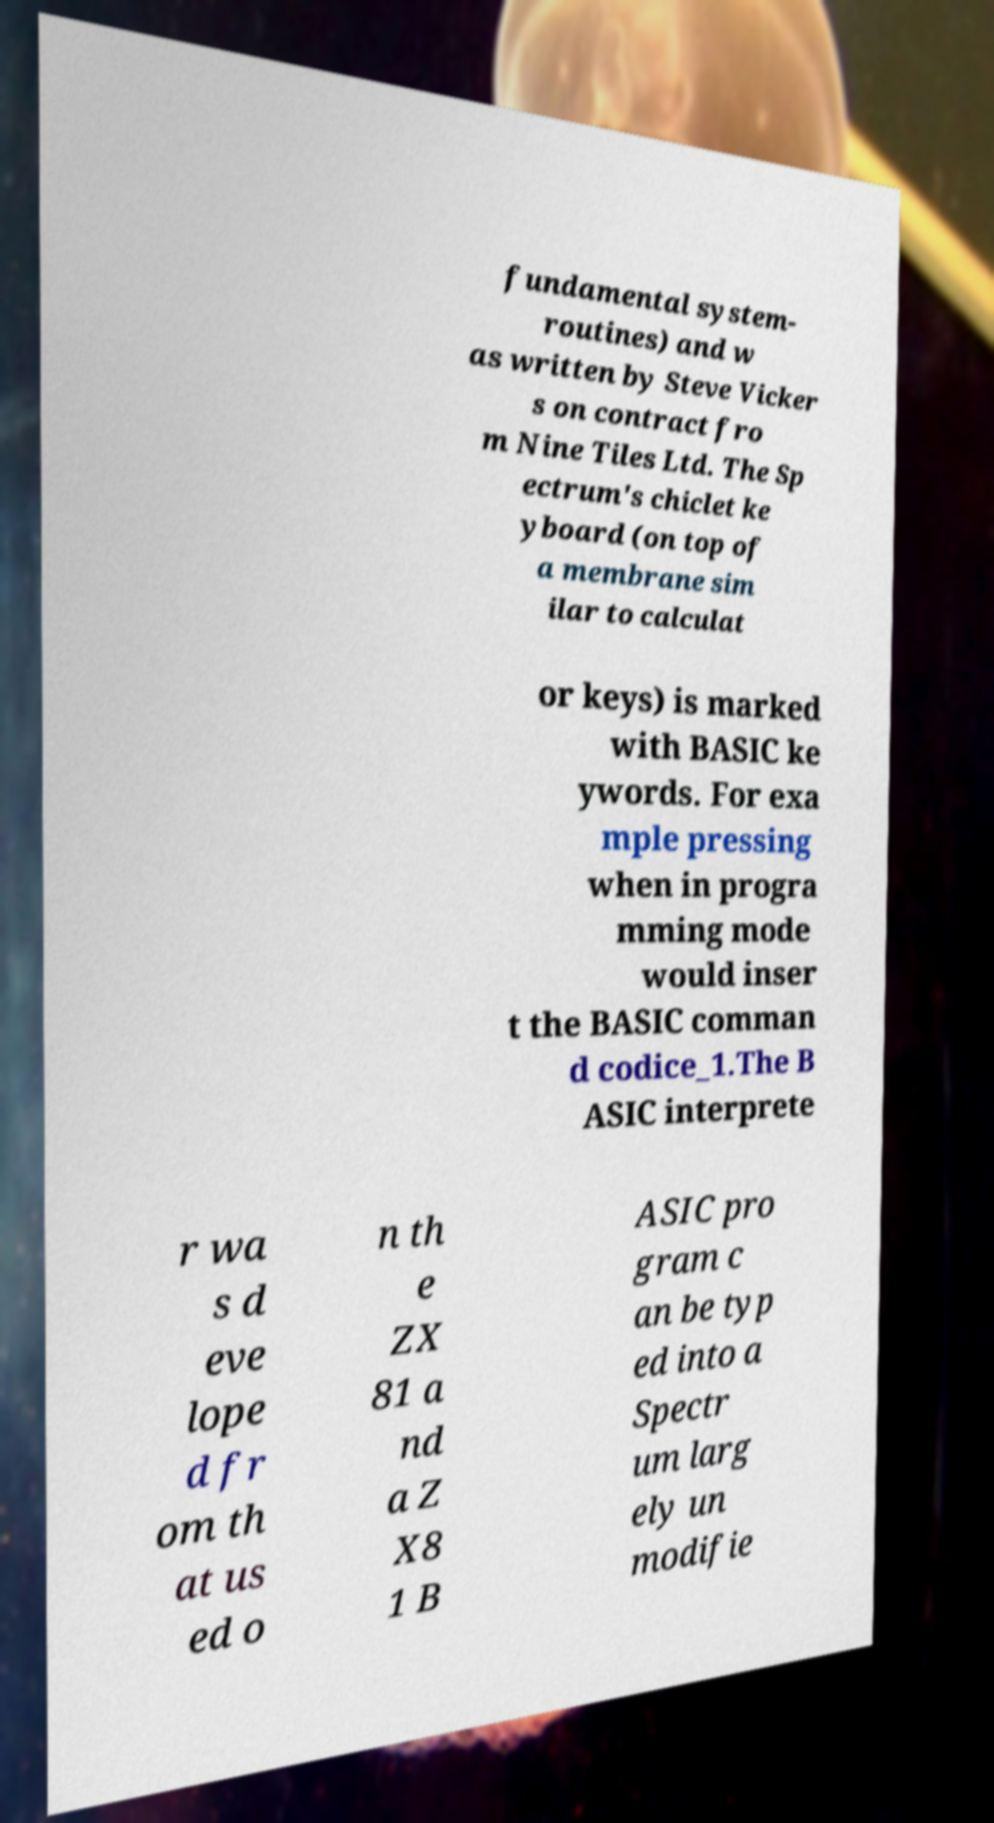What messages or text are displayed in this image? I need them in a readable, typed format. fundamental system- routines) and w as written by Steve Vicker s on contract fro m Nine Tiles Ltd. The Sp ectrum's chiclet ke yboard (on top of a membrane sim ilar to calculat or keys) is marked with BASIC ke ywords. For exa mple pressing when in progra mming mode would inser t the BASIC comman d codice_1.The B ASIC interprete r wa s d eve lope d fr om th at us ed o n th e ZX 81 a nd a Z X8 1 B ASIC pro gram c an be typ ed into a Spectr um larg ely un modifie 